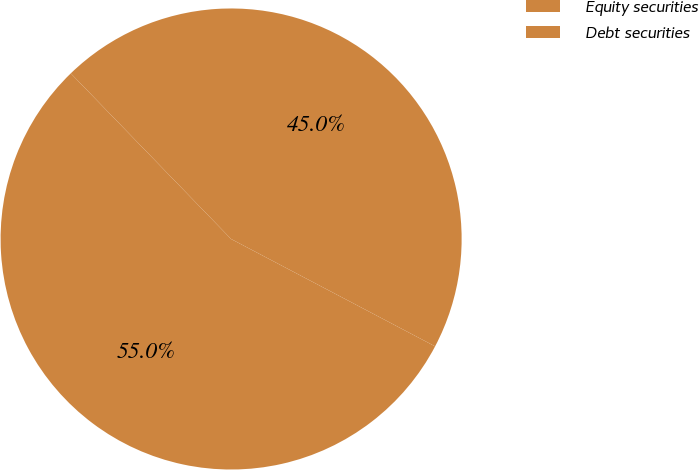Convert chart. <chart><loc_0><loc_0><loc_500><loc_500><pie_chart><fcel>Equity securities<fcel>Debt securities<nl><fcel>44.95%<fcel>55.05%<nl></chart> 